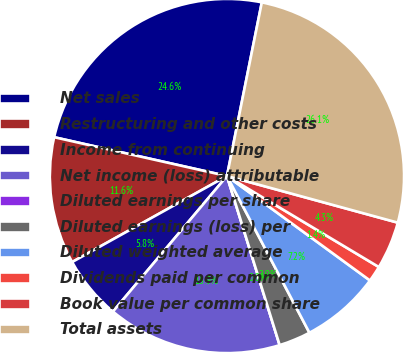Convert chart to OTSL. <chart><loc_0><loc_0><loc_500><loc_500><pie_chart><fcel>Net sales<fcel>Restructuring and other costs<fcel>Income from continuing<fcel>Net income (loss) attributable<fcel>Diluted earnings per share<fcel>Diluted earnings (loss) per<fcel>Diluted weighted average<fcel>Dividends paid per common<fcel>Book value per common share<fcel>Total assets<nl><fcel>24.64%<fcel>11.59%<fcel>5.8%<fcel>15.94%<fcel>0.0%<fcel>2.9%<fcel>7.25%<fcel>1.45%<fcel>4.35%<fcel>26.09%<nl></chart> 